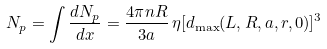<formula> <loc_0><loc_0><loc_500><loc_500>N _ { p } = \int \frac { d N _ { p } } { d x } = \frac { 4 \pi n R } { 3 a } \, \eta [ d _ { \max } ( L , R , a , r , 0 ) ] ^ { 3 }</formula> 